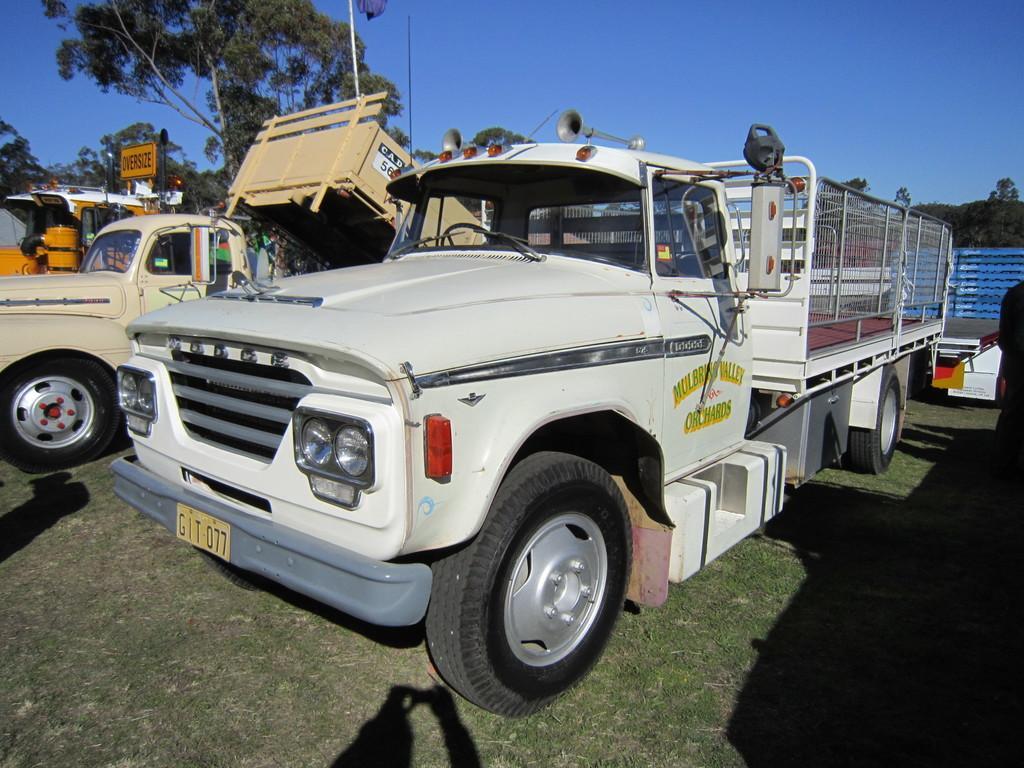Could you give a brief overview of what you see in this image? In this image we can see vehicles on the grassy land. We can see trees and the sky at the top of the image. 